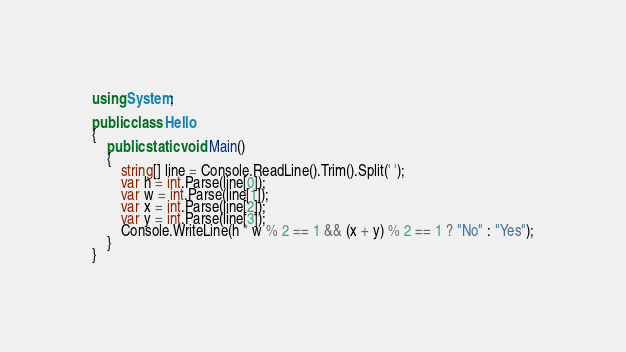Convert code to text. <code><loc_0><loc_0><loc_500><loc_500><_C#_>using System;

public class Hello
{
    public static void Main()
    {
        string[] line = Console.ReadLine().Trim().Split(' ');
        var h = int.Parse(line[0]);
        var w = int.Parse(line[1]);
        var x = int.Parse(line[2]);
        var y = int.Parse(line[3]);
        Console.WriteLine(h * w % 2 == 1 && (x + y) % 2 == 1 ? "No" : "Yes");
    }
}

</code> 